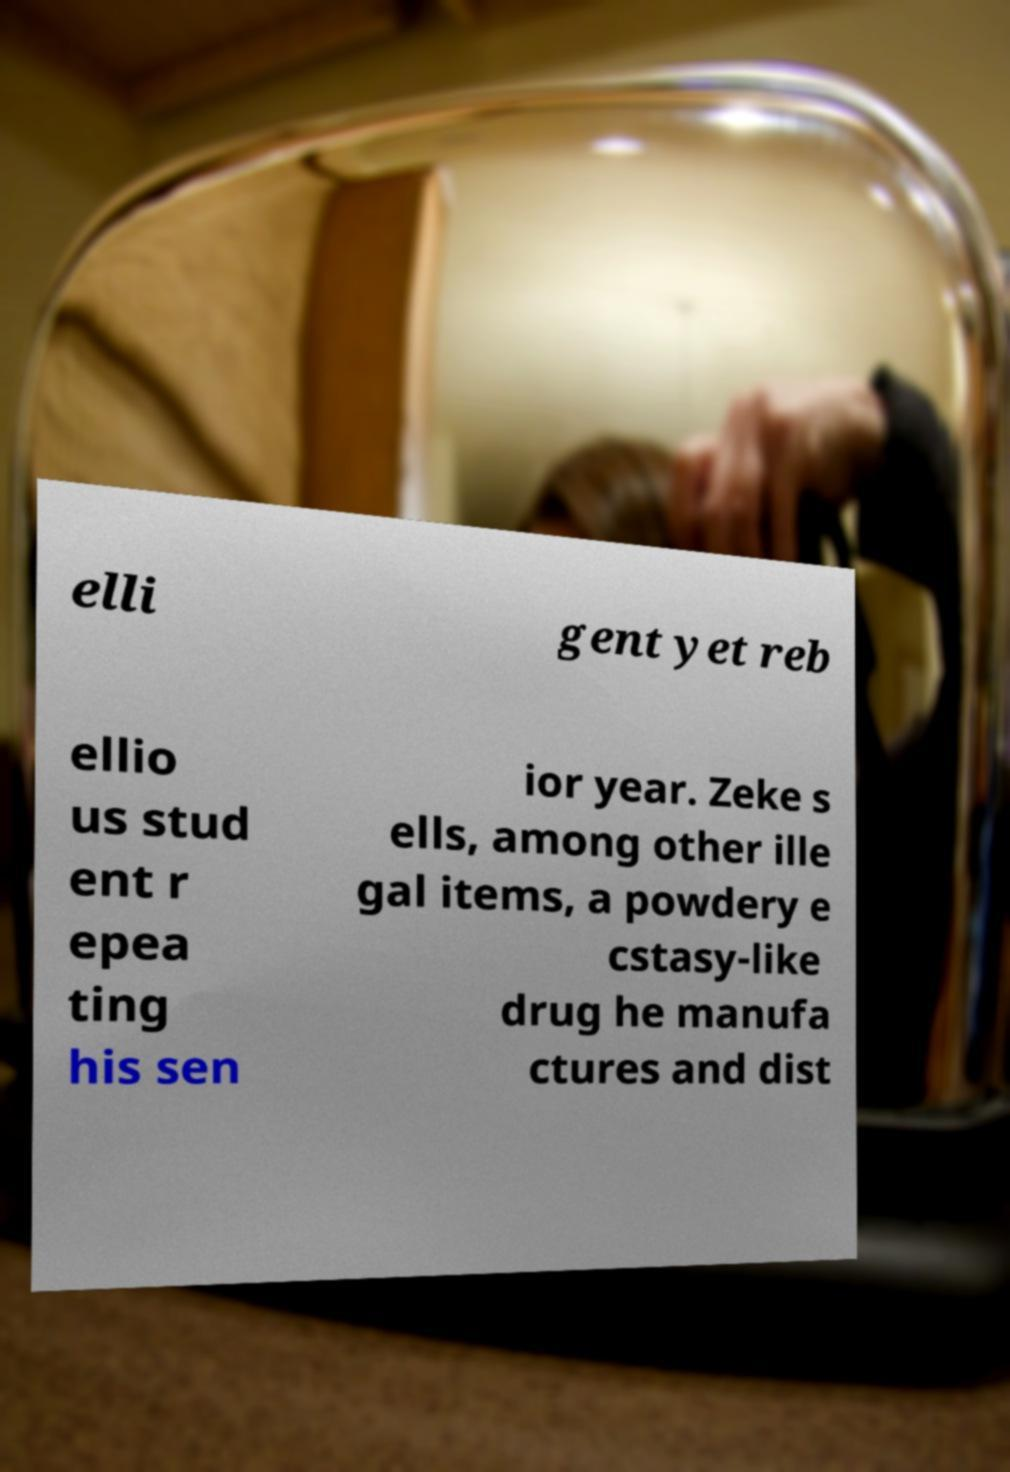Could you extract and type out the text from this image? elli gent yet reb ellio us stud ent r epea ting his sen ior year. Zeke s ells, among other ille gal items, a powdery e cstasy-like drug he manufa ctures and dist 